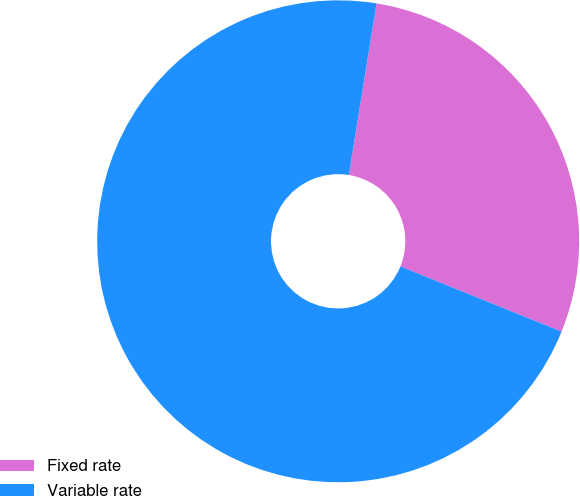<chart> <loc_0><loc_0><loc_500><loc_500><pie_chart><fcel>Fixed rate<fcel>Variable rate<nl><fcel>28.57%<fcel>71.43%<nl></chart> 